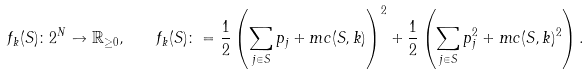<formula> <loc_0><loc_0><loc_500><loc_500>f _ { k } ( S ) \colon 2 ^ { N } \to \mathbb { R } _ { \geq 0 } , \quad f _ { k } ( S ) \colon = \frac { 1 } { 2 } \left ( \sum _ { j \in S } p _ { j } + m c ( S , k ) \right ) ^ { 2 } + \frac { 1 } { 2 } \left ( \sum _ { j \in S } p _ { j } ^ { 2 } + m c ( S , k ) ^ { 2 } \right ) .</formula> 